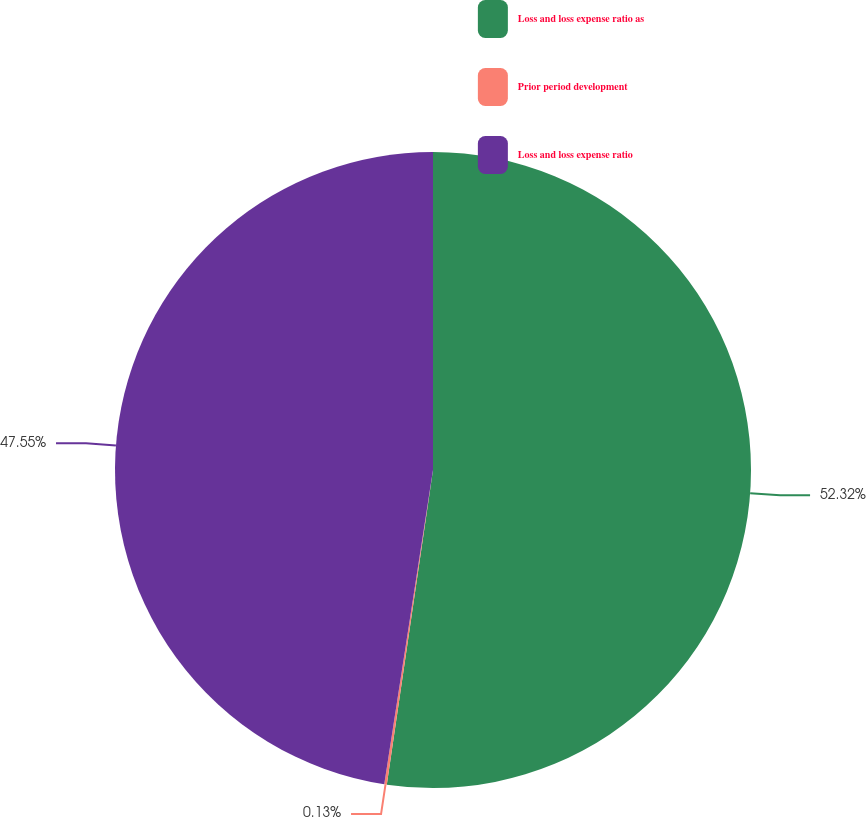Convert chart to OTSL. <chart><loc_0><loc_0><loc_500><loc_500><pie_chart><fcel>Loss and loss expense ratio as<fcel>Prior period development<fcel>Loss and loss expense ratio<nl><fcel>52.32%<fcel>0.13%<fcel>47.55%<nl></chart> 